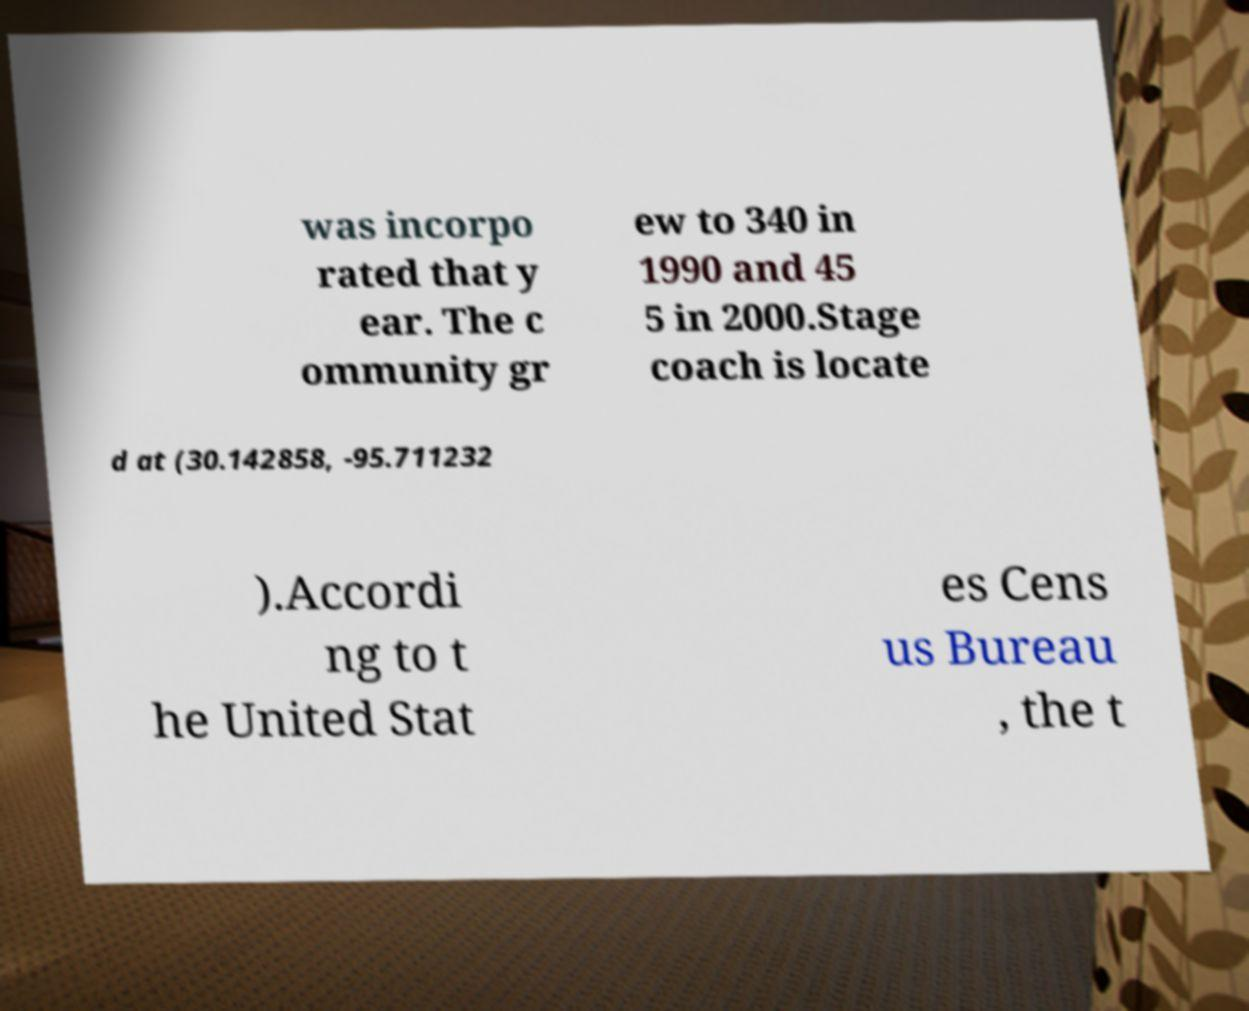I need the written content from this picture converted into text. Can you do that? was incorpo rated that y ear. The c ommunity gr ew to 340 in 1990 and 45 5 in 2000.Stage coach is locate d at (30.142858, -95.711232 ).Accordi ng to t he United Stat es Cens us Bureau , the t 